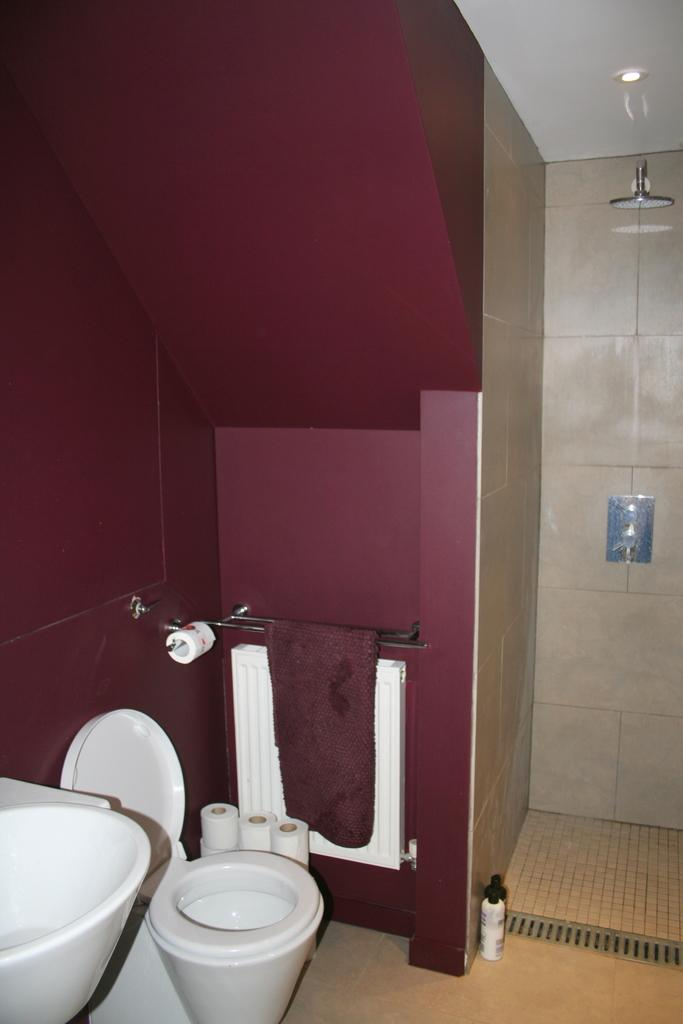What is the main object in the image? There is a toilet seat in the image. What items are present for personal hygiene? There are tissue paper rolls in the image. What can be seen on the walls in the image? There is a wall in the image. What is the source of light in the image? There are lights on the ceiling in the image. What is used for washing in the image? There is a shower head and taps in the image. What is the container in the image? There is a bottle in the image. What type of room is shown in the image? The image is an inside view of a bathroom. What type of lumber is being mined in the image? There is no lumber or mining activity present in the image; it is a bathroom scene. 